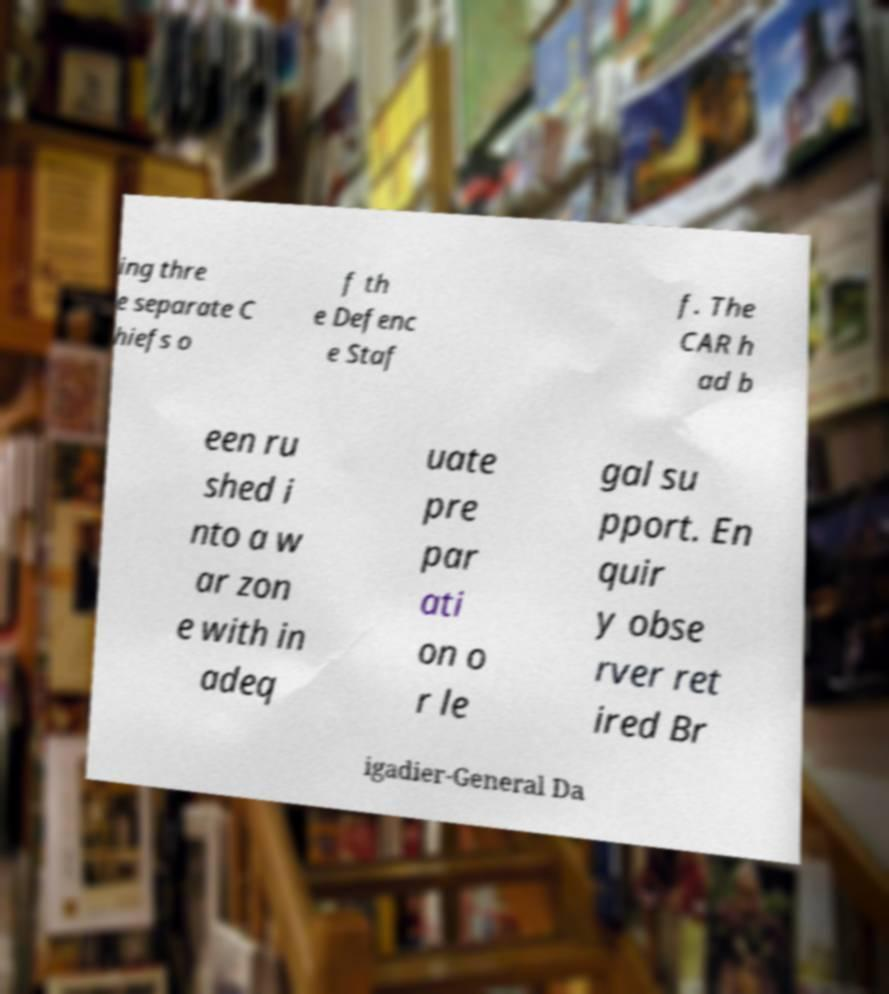I need the written content from this picture converted into text. Can you do that? ing thre e separate C hiefs o f th e Defenc e Staf f. The CAR h ad b een ru shed i nto a w ar zon e with in adeq uate pre par ati on o r le gal su pport. En quir y obse rver ret ired Br igadier-General Da 